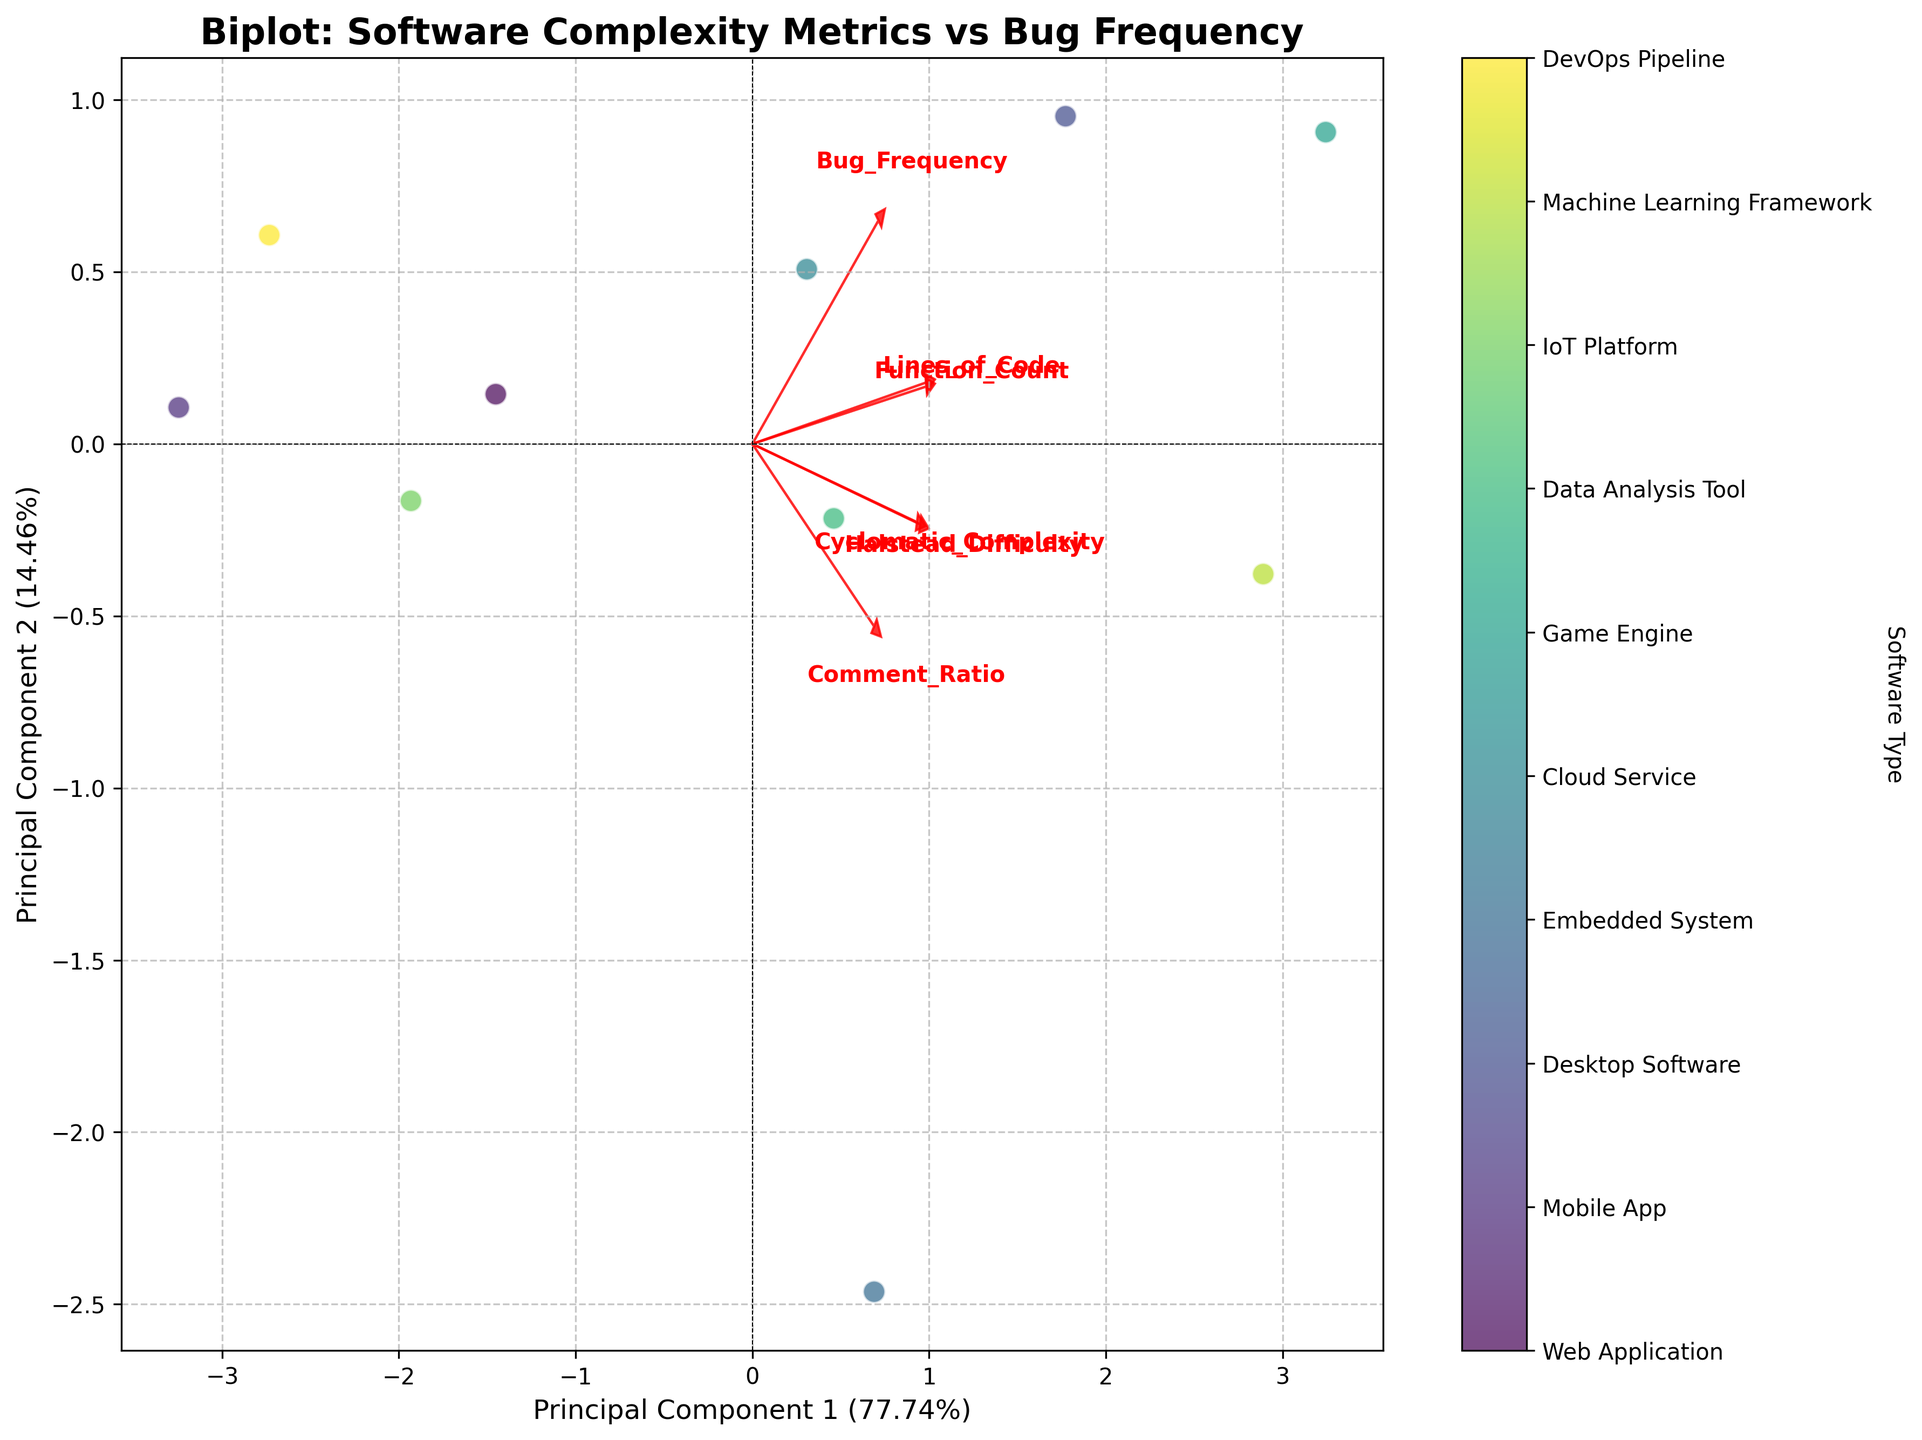What is the title of the Biplot? The title of a plot is usually found at the top center of the plot, which can be read directly without any calculation or interpretation.
Answer: Biplot: Software Complexity Metrics vs Bug Frequency How many software types are represented in the scatter plot? Count the distinct colored points in the scatter plot, each corresponding to a unique software type.
Answer: 10 What are the labels of the two principal component axes? Look at the text descriptions placed beside the x-axis and y-axis which show the components' names and their explained variance ratio in percentage.
Answer: Principal Component 1 and Principal Component 2 Which feature has the largest vector in the biplot? Observing the length of the red arrows representing the features in the plot, identify which one extends the furthest from the origin.
Answer: Lines_of_Code Which software type has the highest Bug Frequency based on the chart? Cross-reference the scatter plot with the colorbar legend, identifying the data point with the highest y-value and matching it to its software type.
Answer: Desktop Software Compare the Bug Frequency of 'Embedded System' and 'Cloud Service'. Which one is higher? Locate the points for 'Embedded System' and 'Cloud Service' on the scatter plot, and compare their y-coordinates, which represent Bug Frequency.
Answer: Cloud Service Which features are correlated with Bug Frequency? Look for the red vectors that point in the same direction as the vector for Bug Frequency. Features pointing in the same or opposite direction can be considered correlated.
Answer: Cyclomatic_Complexity, Lines_of_Code, Function_Count, Halstead_Difficulty What is the explained variance of the first principal component? Read the label on the x-axis which includes the explained variance ratio of the first principal component expressed as a percentage.
Answer: Approximately 44% Considering Cyclomatic_Complexity and Halstead_Difficulty, which has a stronger influence on the first principal component? Compare the projections of the feature vectors Cyclomatic_Complexity and Halstead_Difficulty on the x-axis, noting which one has a larger x-coordinate.
Answer: Cyclomatic_Complexity How does the Comment_Ratio feature vector relate to the other features in the biplot? Observe the direction and length of the Comment_Ratio vector relative to the others in the biplot to determine its correlation and strength of influence.
Answer: It has a weak influence and is relatively orthogonal 